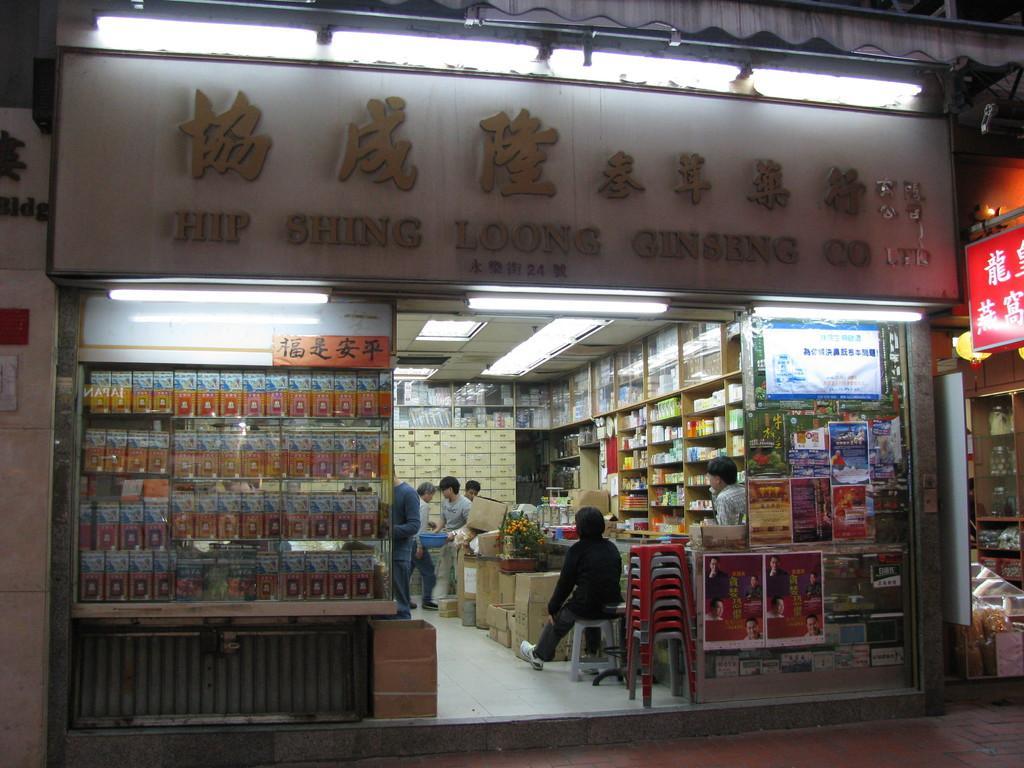Can you describe this image briefly? In the picture I can see the store. I can see the name indication board and lighting arrangement at the top of the picture. I can see the materials on the shelves. There are stock boxes on the floor. I can see a man sitting on the chair and there is a set of chairs on the floor. 